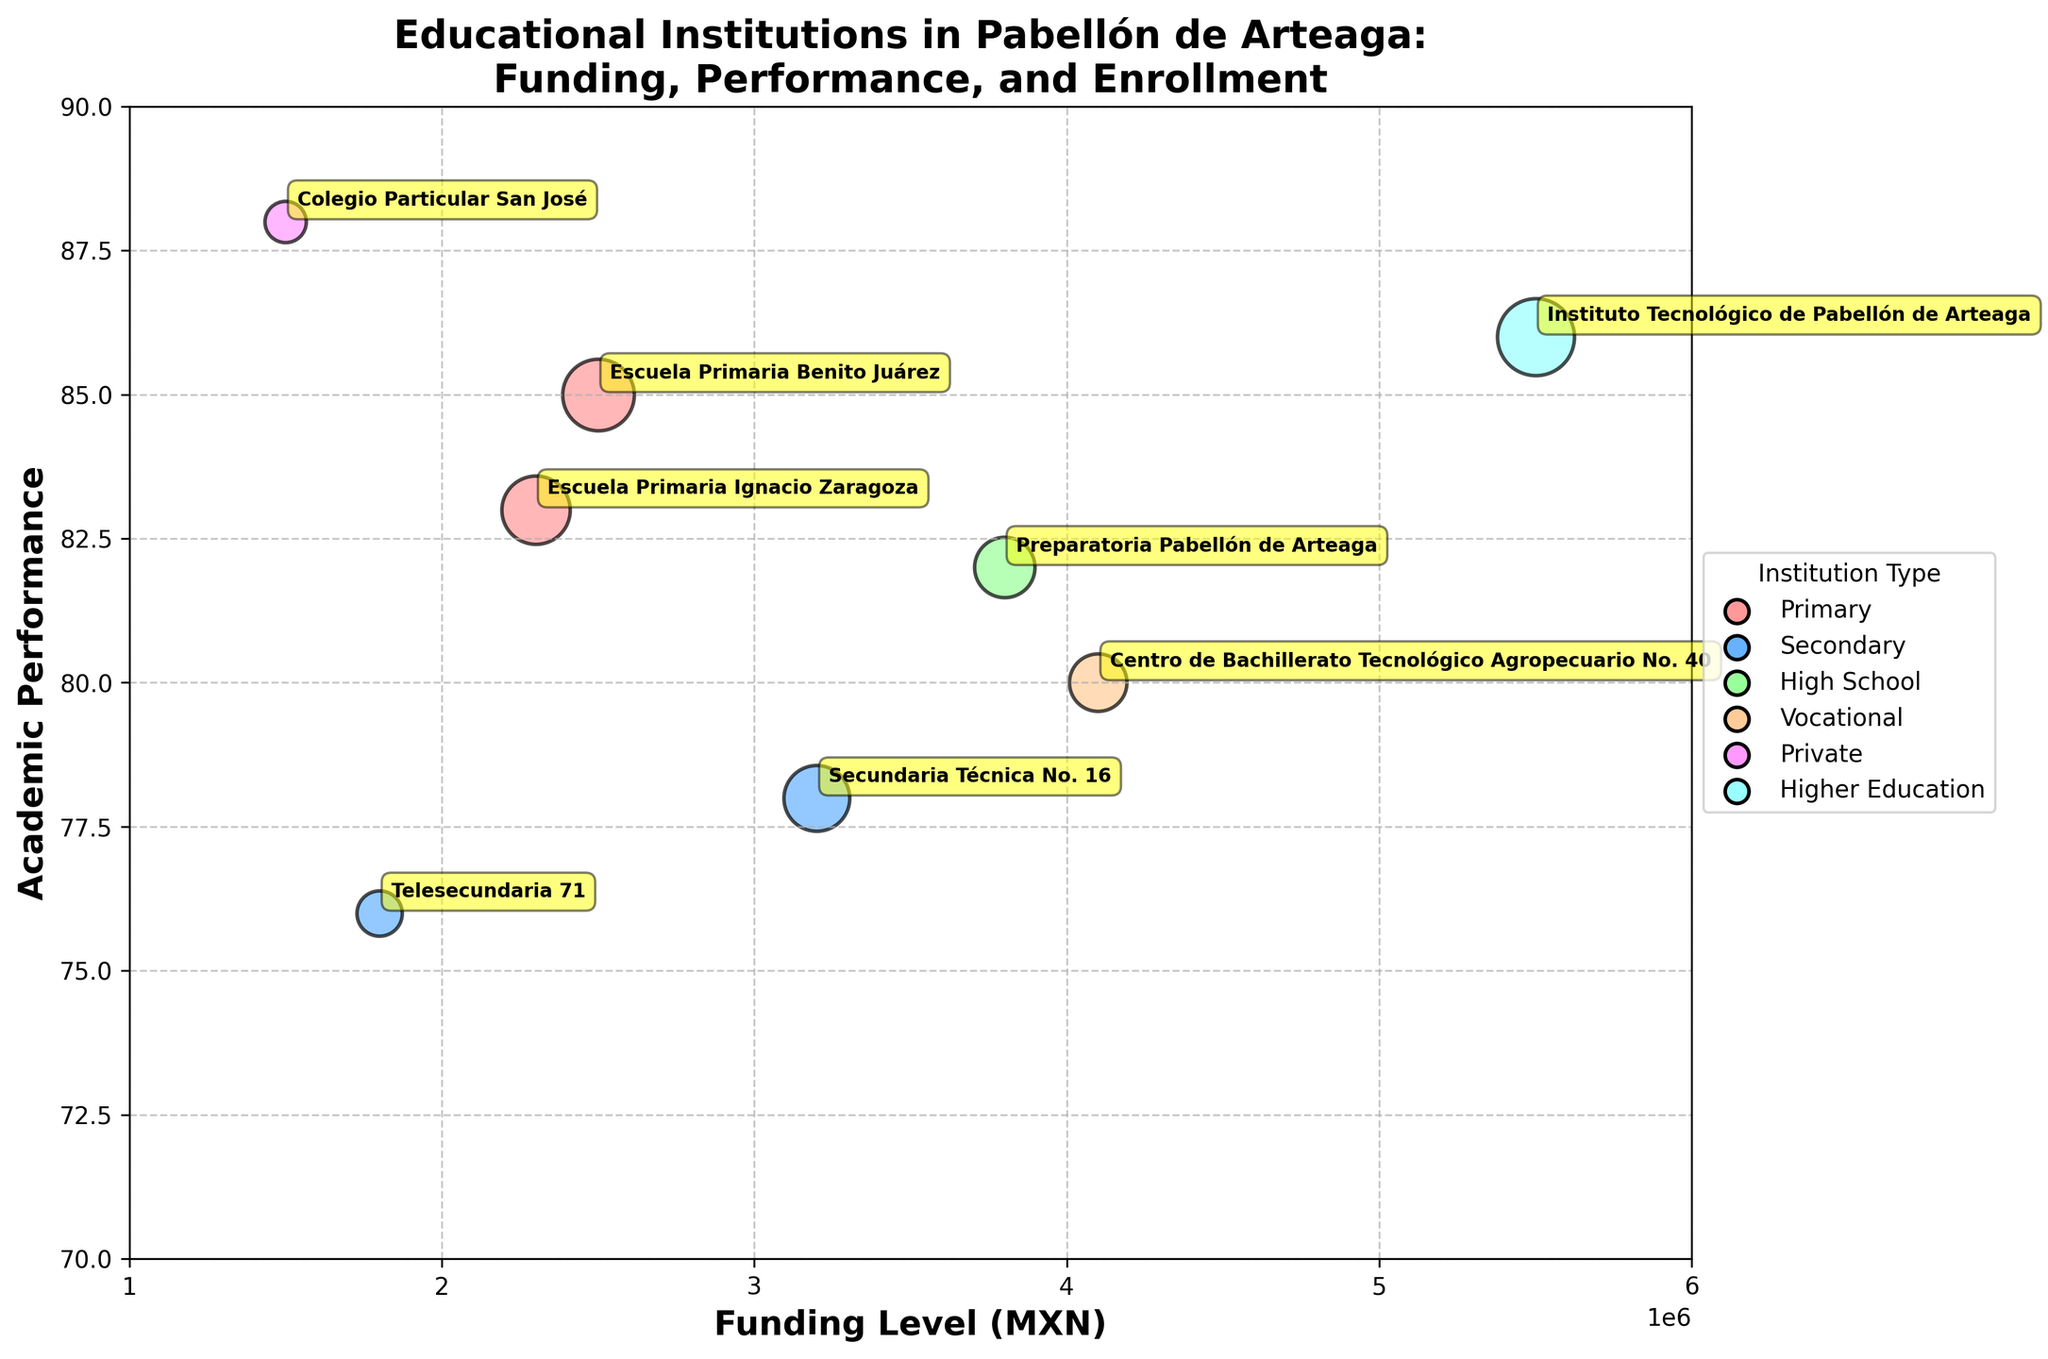What is the title of the figure? The title of the figure is usually displayed at the top. In this case, it is bold and spans two lines, making it easy to identify.
Answer: Educational Institutions in Pabellón de Arteaga: Funding, Performance, and Enrollment Which institution has the highest academic performance? Look at the bubble that reaches the highest vertical position on the academic performance axis. The annotated label should give the institution's name.
Answer: Colegio Particular San José What is the range of the funding levels for the displayed institutions? Check the x-axis for the minimum and maximum values of the funding levels displayed.
Answer: 1,000,000 to 5,500,000 MXN How many primary schools are shown in the figure? Look for the bubbles with the primary school color and count the number of bubbles that match it.
Answer: 2 Which institution has the largest student enrollment? The largest bubble size represents the highest student enrollment. The annotated label indicates the institution.
Answer: Instituto Tecnológico de Pabellón de Arteaga Which institution has the smallest student enrollment? The smallest bubble size represents the lowest student enrollment. The annotated label indicates the institution.
Answer: Colegio Particular San José What is the funding level of "Secundaria Técnica No. 16"? Find the bubble labeled "Secundaria Técnica No. 16" and look at its position along the x-axis to determine the funding level.
Answer: 3,200,000 MXN Compare the academic performance of the two primary schools. Which one performs better? Identify the bubbles for the primary schools and compare their positions along the academic performance y-axis. The primary school that is higher on the y-axis performs better.
Answer: Escuela Primaria Benito Juárez Which institution has a higher funding level, "Preparatoria Pabellón de Arteaga" or "Centro de Bachillerato Tecnológico Agropecuario No. 40"? Find the positions of both bubbles on the funding level x-axis and compare them.
Answer: Centro de Bachillerato Tecnológico Agropecuario No. 40 Which type of educational institution generally has the highest funding levels? Examine the bubbles of each type and see which type often appears further along the x-axis towards higher funding levels.
Answer: Higher Education 